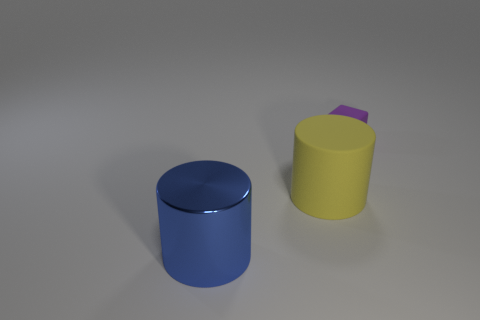The cylinder right of the thing in front of the yellow rubber cylinder is made of what material?
Provide a short and direct response. Rubber. There is a cylinder that is on the right side of the large object that is in front of the big thing behind the large shiny cylinder; what is its size?
Your answer should be compact. Large. Do the purple rubber block and the blue metal object have the same size?
Your answer should be compact. No. Do the matte object on the left side of the small rubber block and the thing behind the yellow cylinder have the same shape?
Your answer should be very brief. No. Are there any objects in front of the rubber cube on the right side of the blue object?
Give a very brief answer. Yes. Is there a big gray block?
Ensure brevity in your answer.  No. How many blue things have the same size as the yellow rubber cylinder?
Offer a terse response. 1. What number of things are both on the left side of the small purple matte thing and on the right side of the blue cylinder?
Give a very brief answer. 1. There is a cylinder that is behind the metallic thing; does it have the same size as the purple cube?
Make the answer very short. No. What is the size of the thing that is made of the same material as the big yellow cylinder?
Make the answer very short. Small. 